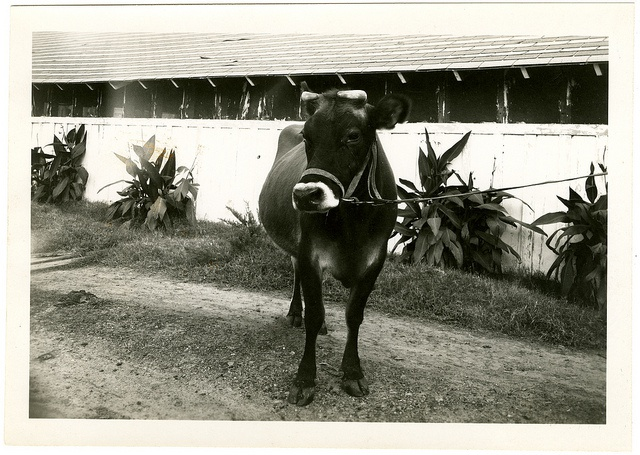Describe the objects in this image and their specific colors. I can see cow in white, black, gray, darkgreen, and darkgray tones, potted plant in white, black, gray, darkgreen, and ivory tones, potted plant in white, black, ivory, gray, and darkgray tones, potted plant in white, black, gray, and darkgray tones, and potted plant in white, black, gray, darkgreen, and darkgray tones in this image. 